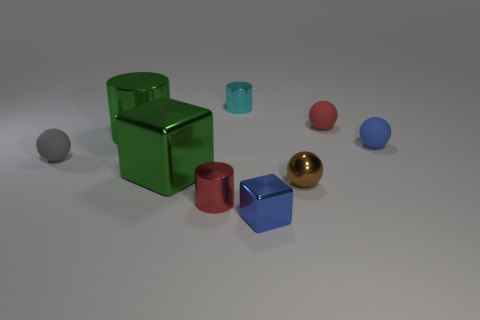What number of tiny cyan shiny things have the same shape as the brown object?
Your response must be concise. 0. Are the small red cylinder and the large green cylinder that is behind the blue cube made of the same material?
Offer a terse response. Yes. There is another cube that is made of the same material as the small blue block; what is its size?
Provide a short and direct response. Large. There is a matte thing that is behind the blue rubber object; what size is it?
Your answer should be compact. Small. What number of red cylinders have the same size as the cyan thing?
Give a very brief answer. 1. What is the size of the rubber ball that is the same color as the tiny cube?
Ensure brevity in your answer.  Small. Are there any metallic cylinders that have the same color as the large cube?
Ensure brevity in your answer.  Yes. What color is the shiny sphere that is the same size as the cyan metal cylinder?
Give a very brief answer. Brown. Do the small cube and the sphere that is behind the blue matte thing have the same color?
Provide a succinct answer. No. The metallic sphere is what color?
Your answer should be very brief. Brown. 